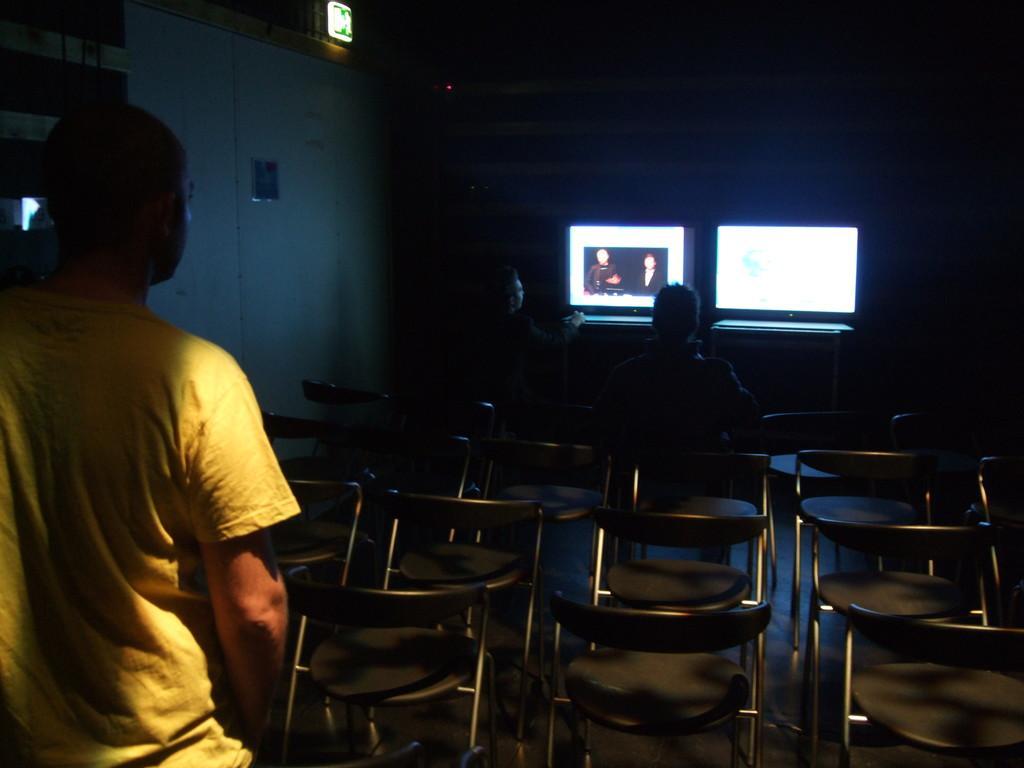Can you describe this image briefly? This man is standing and wearing a yellow t-shirt. These are chairs,there are two persons sitting and watching the screen. 